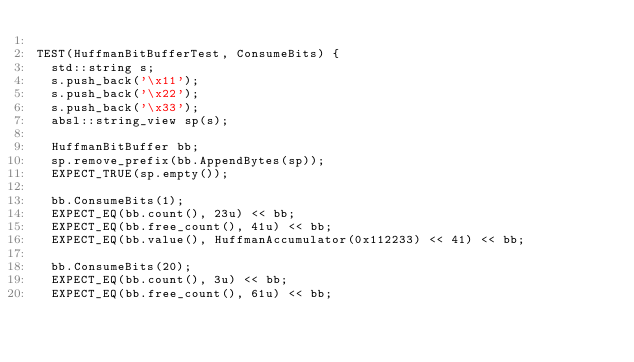Convert code to text. <code><loc_0><loc_0><loc_500><loc_500><_C++_>
TEST(HuffmanBitBufferTest, ConsumeBits) {
  std::string s;
  s.push_back('\x11');
  s.push_back('\x22');
  s.push_back('\x33');
  absl::string_view sp(s);

  HuffmanBitBuffer bb;
  sp.remove_prefix(bb.AppendBytes(sp));
  EXPECT_TRUE(sp.empty());

  bb.ConsumeBits(1);
  EXPECT_EQ(bb.count(), 23u) << bb;
  EXPECT_EQ(bb.free_count(), 41u) << bb;
  EXPECT_EQ(bb.value(), HuffmanAccumulator(0x112233) << 41) << bb;

  bb.ConsumeBits(20);
  EXPECT_EQ(bb.count(), 3u) << bb;
  EXPECT_EQ(bb.free_count(), 61u) << bb;</code> 